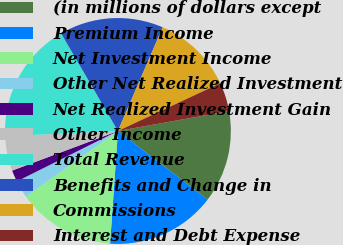Convert chart. <chart><loc_0><loc_0><loc_500><loc_500><pie_chart><fcel>(in millions of dollars except<fcel>Premium Income<fcel>Net Investment Income<fcel>Other Net Realized Investment<fcel>Net Realized Investment Gain<fcel>Other Income<fcel>Total Revenue<fcel>Benefits and Change in<fcel>Commissions<fcel>Interest and Debt Expense<nl><fcel>13.22%<fcel>15.7%<fcel>14.05%<fcel>2.48%<fcel>1.66%<fcel>4.96%<fcel>17.35%<fcel>14.87%<fcel>11.57%<fcel>4.13%<nl></chart> 